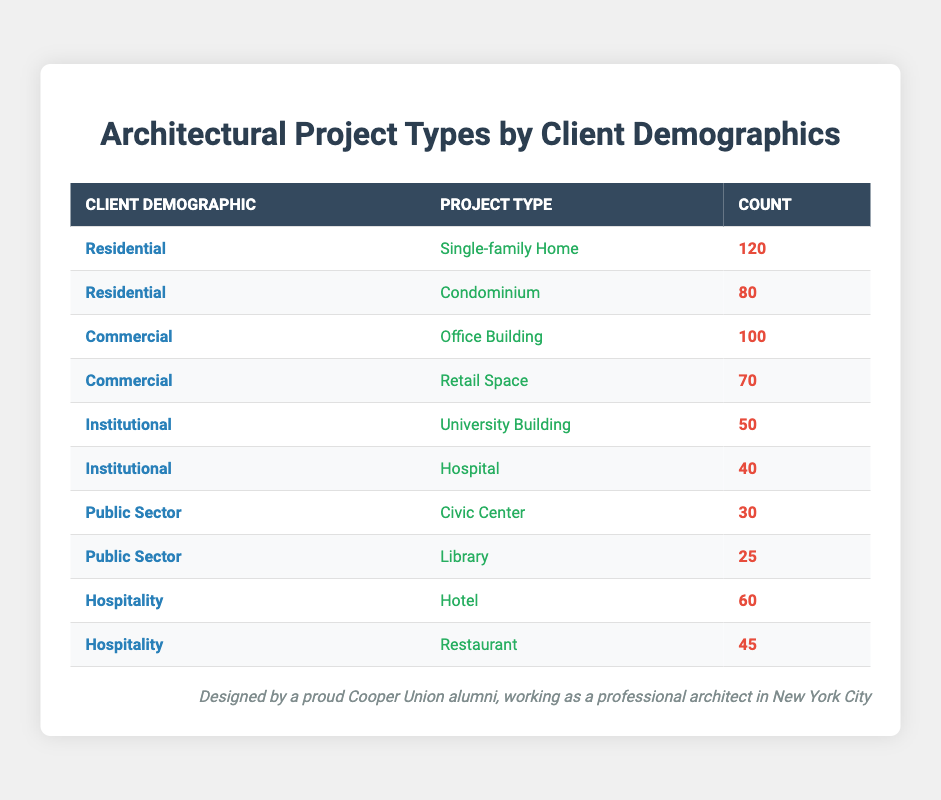What is the count of Single-family Homes under the Residential demographic? The table directly lists the Residential demographic and the corresponding count for Single-family Homes is clearly shown as 120.
Answer: 120 What is the total count of projects for the Institutional demographic? We look at both project types under Institutional: University Building (50) and Hospital (40). Adding these gives: 50 + 40 = 90.
Answer: 90 Does the Commercial sector have more projects than the Residential sector? The total count for Commercial projects is Office Building (100) + Retail Space (70) = 170. The total for Residential is Single-family Home (120) + Condominium (80) = 200. Since 170 < 200, the Commercial sector does not have more projects.
Answer: No What project type has the highest count among all categories? By scanning the counts in the table, the highest count is for Single-family Home at 120, which is greater than any other project type count presented.
Answer: Single-family Home What is the difference in counts between the Office Building and the Library? The count for Office Building is 100, and for Library, it is 25. The difference is calculated as 100 - 25 = 75.
Answer: 75 How many total projects are listed in the Hospitality demographic? The projects listed under Hospitality are Hotel (60) and Restaurant (45). Adding these gives: 60 + 45 = 105.
Answer: 105 Is there a greater count of Civic Centers than University Buildings? The count for Civic Center is 30, and for University Building, it is 50. Since 30 < 50, there is not a greater count for Civic Centers.
Answer: No What is the average count of projects in the Public Sector category? The Public Sector has Civic Center (30) and Library (25). The total count is 30 + 25 = 55. To find the average: 55 divided by 2 (number of project types) = 27.5.
Answer: 27.5 Which demographic has the least number of projects? Reviewing all counts shows Public Sector has the lowest single count of Library at 25, making it the demographic with the least projects overall.
Answer: Public Sector 